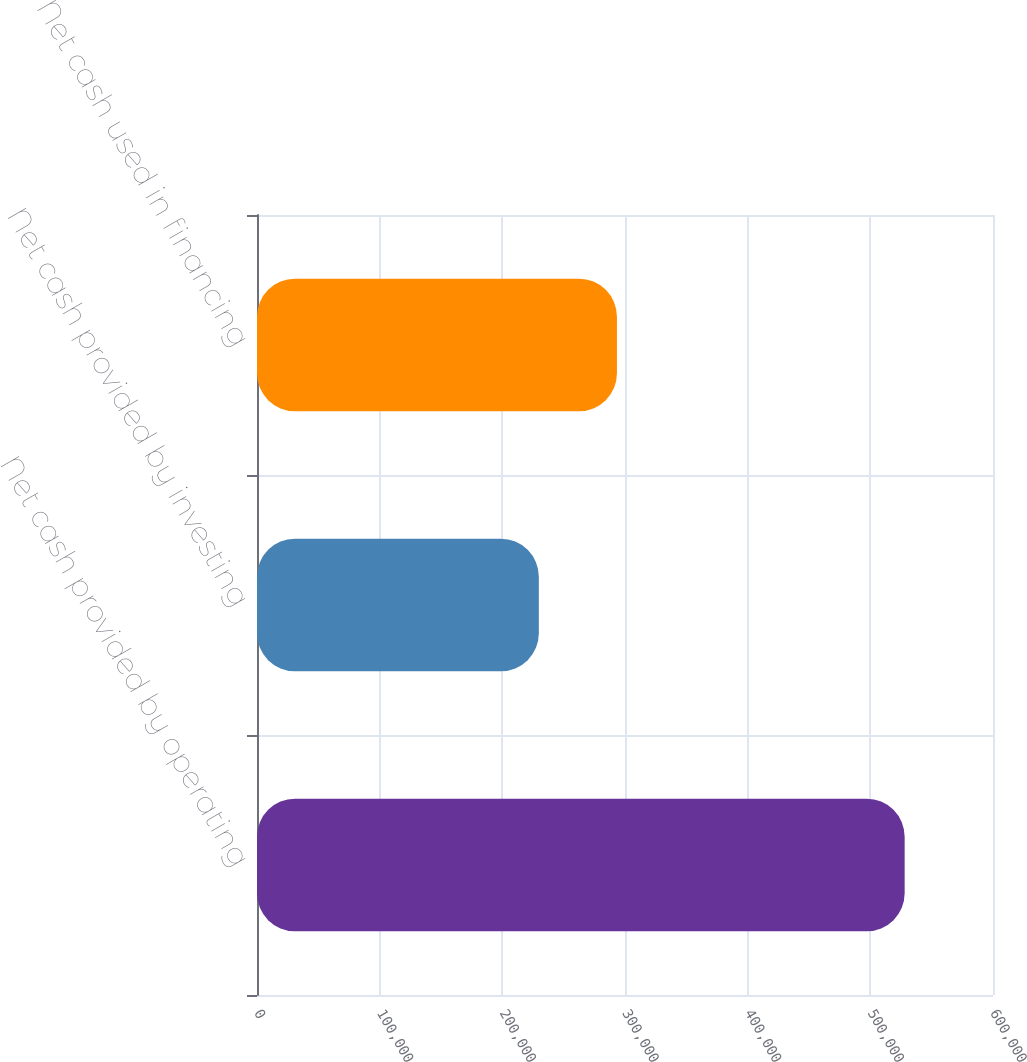Convert chart to OTSL. <chart><loc_0><loc_0><loc_500><loc_500><bar_chart><fcel>Net cash provided by operating<fcel>Net cash provided by investing<fcel>Net cash used in financing<nl><fcel>527979<fcel>229756<fcel>293443<nl></chart> 